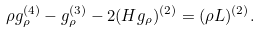<formula> <loc_0><loc_0><loc_500><loc_500>\rho g _ { \rho } ^ { ( 4 ) } - g _ { \rho } ^ { ( 3 ) } - 2 ( H g _ { \rho } ) ^ { ( 2 ) } = ( \rho L ) ^ { ( 2 ) } .</formula> 